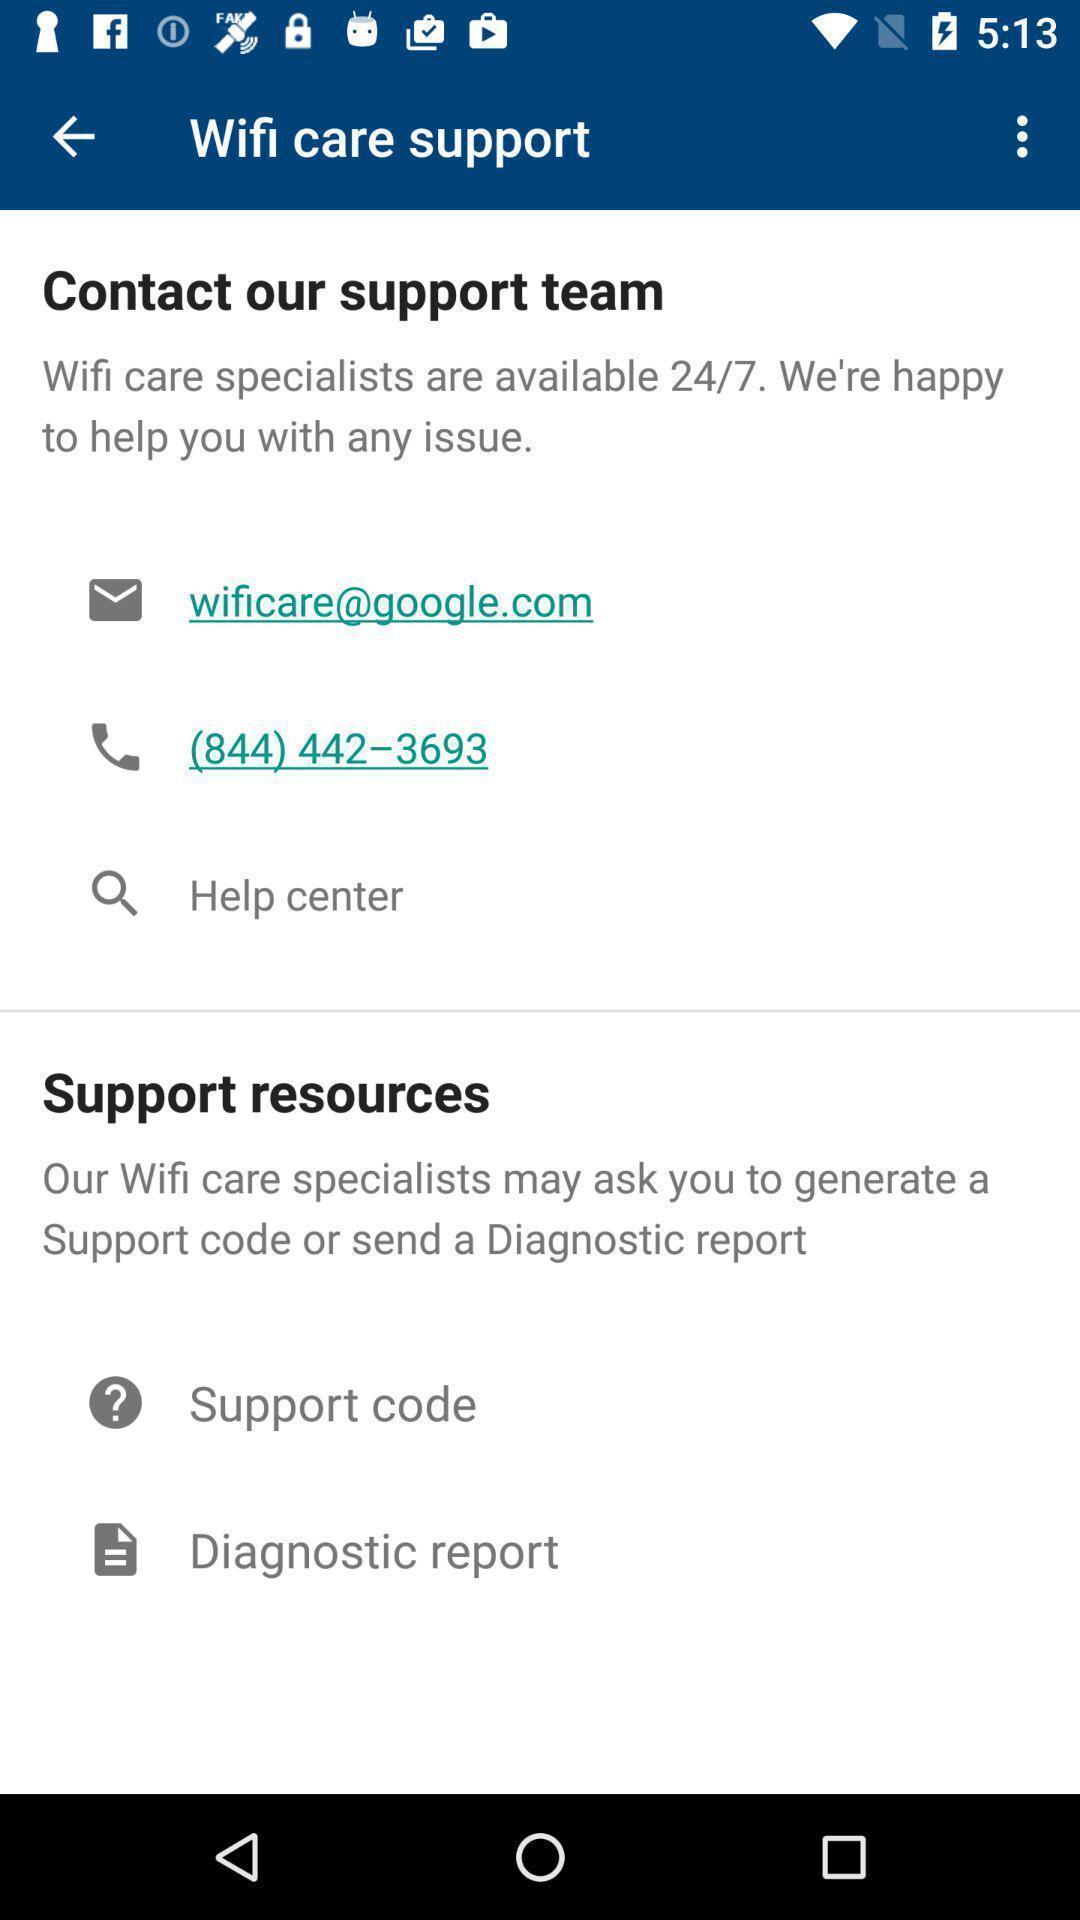Describe the key features of this screenshot. Support page in a wifi app. 